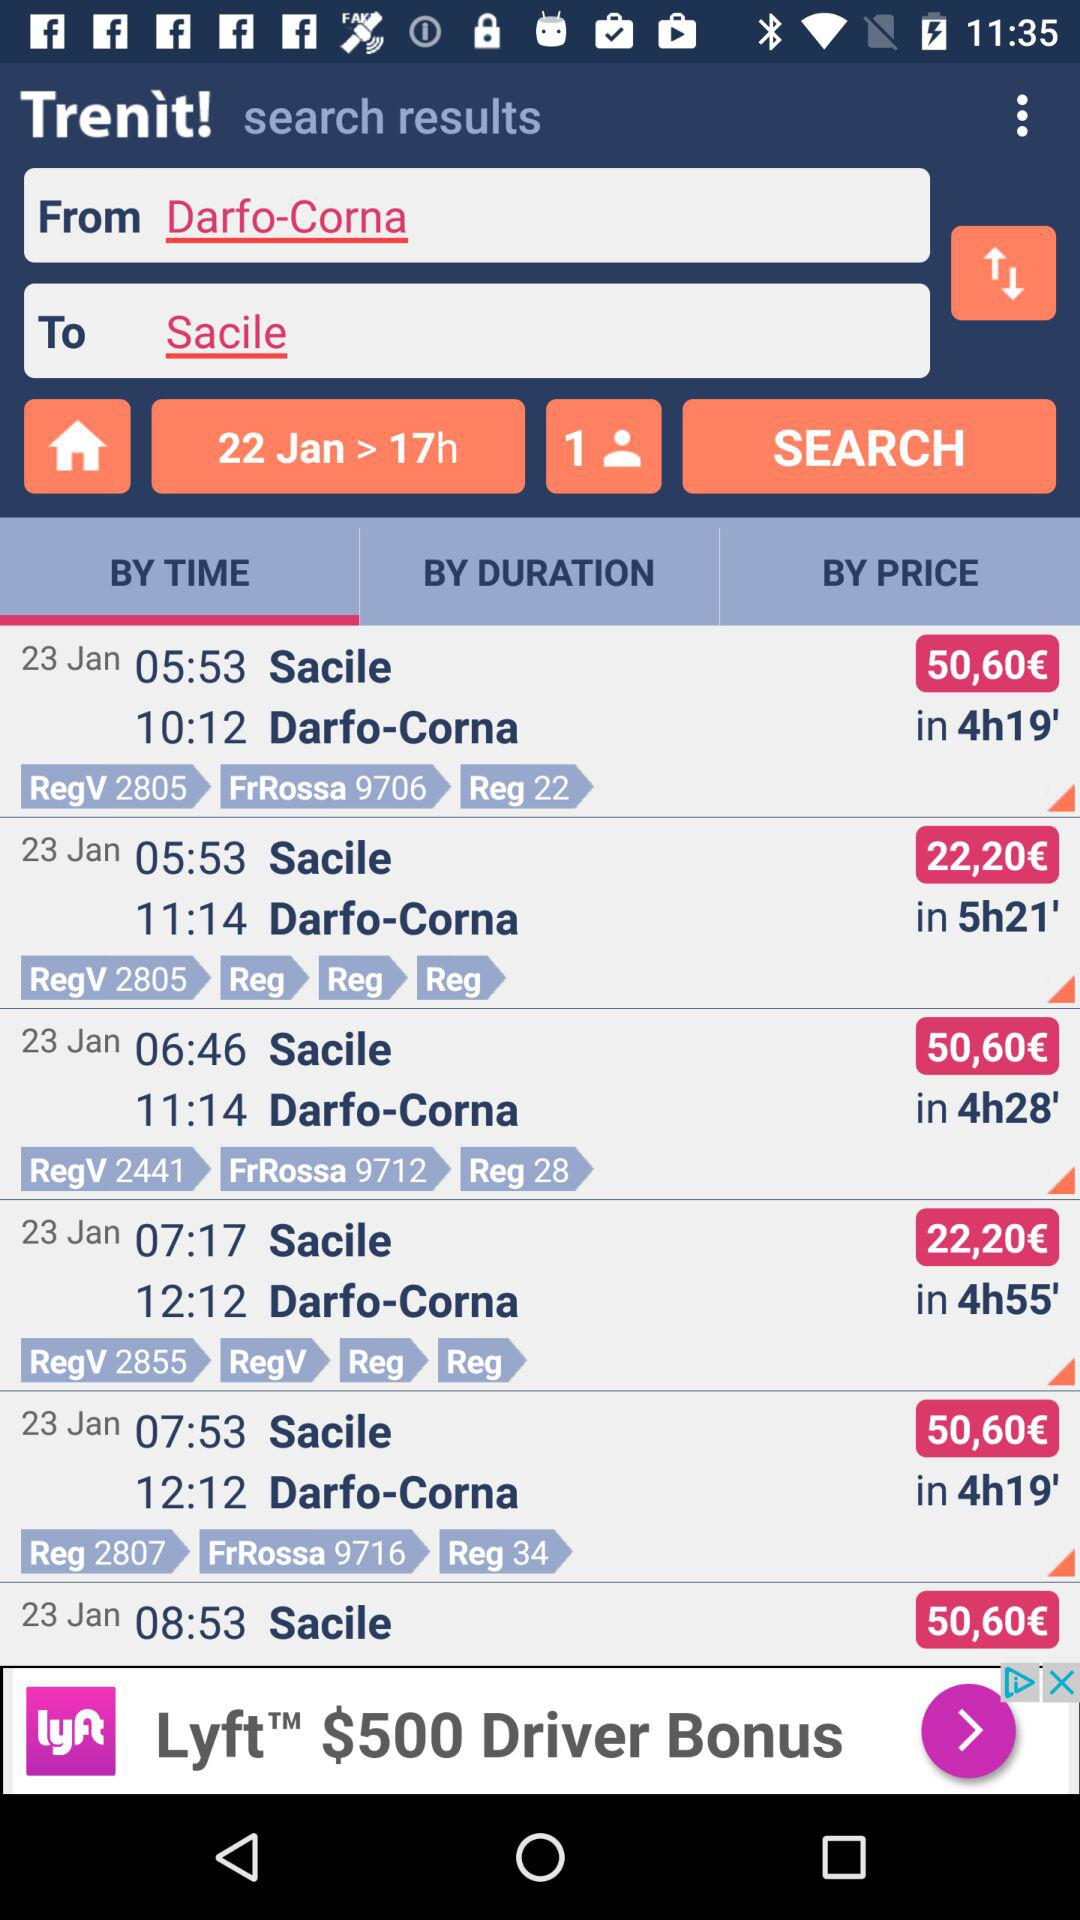What is the starting location? The starting location is "Darfo-Corna". 